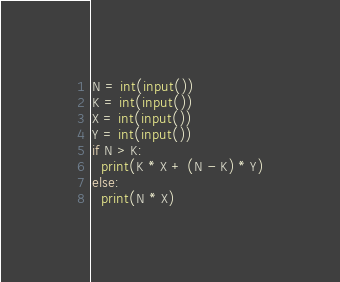Convert code to text. <code><loc_0><loc_0><loc_500><loc_500><_Python_>N = int(input()) 
K = int(input()) 
X = int(input()) 
Y = int(input()) 
if N > K:
  print(K * X + (N - K) * Y)
else:
  print(N * X)</code> 